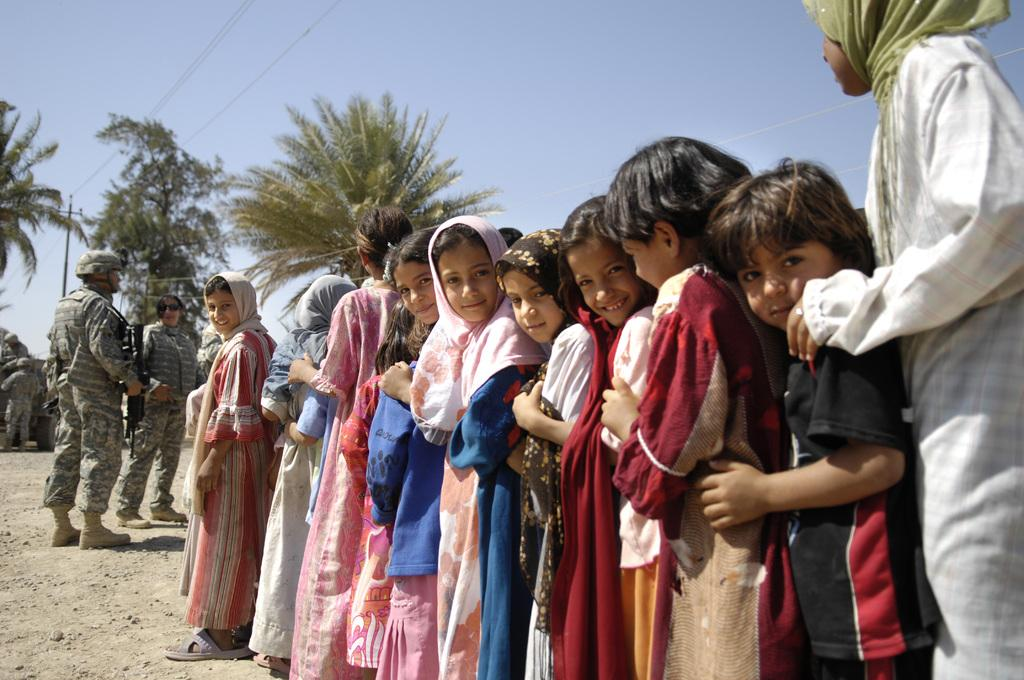What is the main subject of the image? The main subject of the image is a group of people. Can you describe the two army persons in the image? Two army persons are standing on the right side of the image. What can be seen in the background of the image? There are trees in the background of the image. What is visible at the top of the image? The sky is visible at the top of the image. What type of bell can be heard ringing in the image? There is no bell present or ringing in the image. What are the army persons using to hit the sticks together in the image? There is no indication of sticks or any action involving them in the image. 